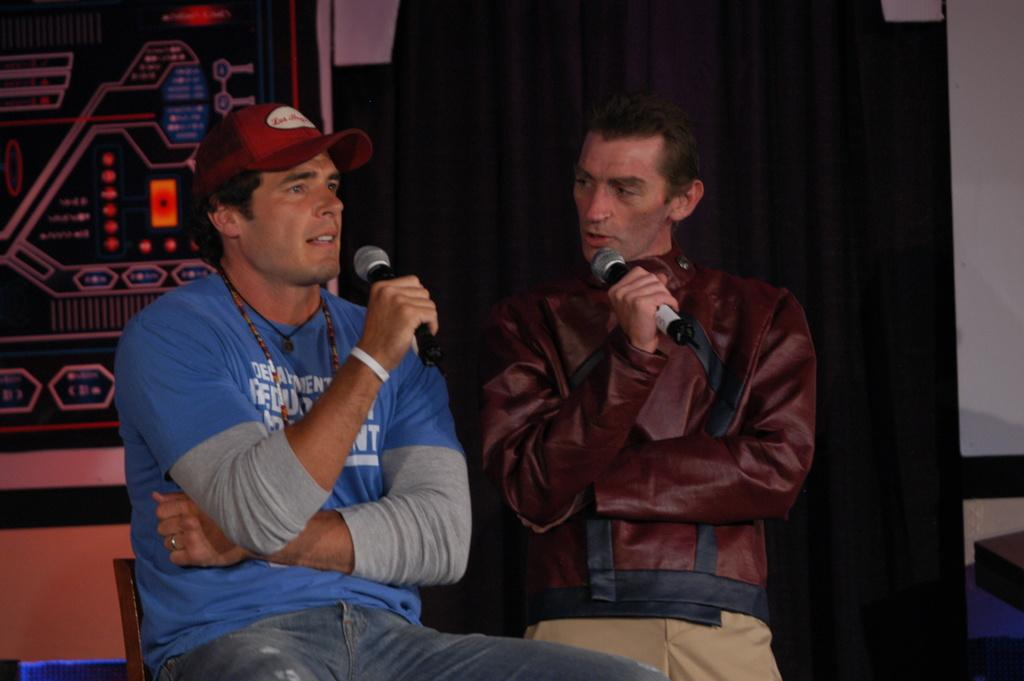How many people are in the image? There are two men in the image. What are the men holding in the image? The men are holding microphones. What is the position of one of the men in the image? One man is sitting on a chair. What can be seen in the background of the image? There is a board, a curtain, and a wall in the background of the image. What type of grain is being harvested by the bears in the image? There are no bears present in the image, and therefore no grain harvesting can be observed. 